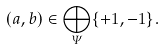Convert formula to latex. <formula><loc_0><loc_0><loc_500><loc_500>( a , b ) \in \bigoplus _ { \varPsi } \{ + 1 , - 1 \} .</formula> 